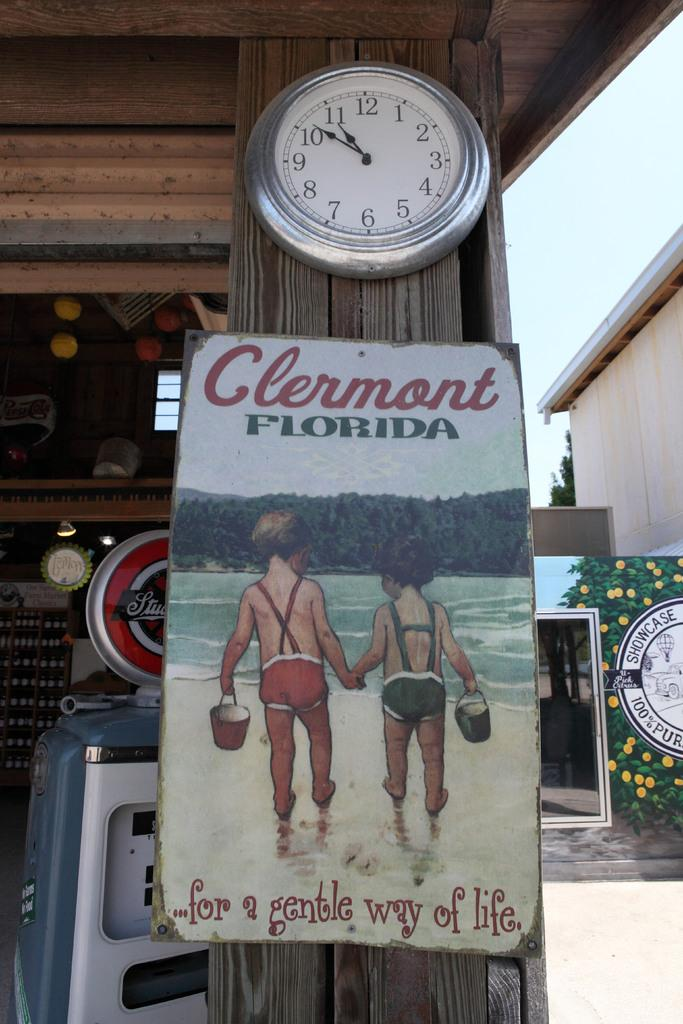<image>
Summarize the visual content of the image. An old sign for Clermont Florida features children in their bathing suits. 